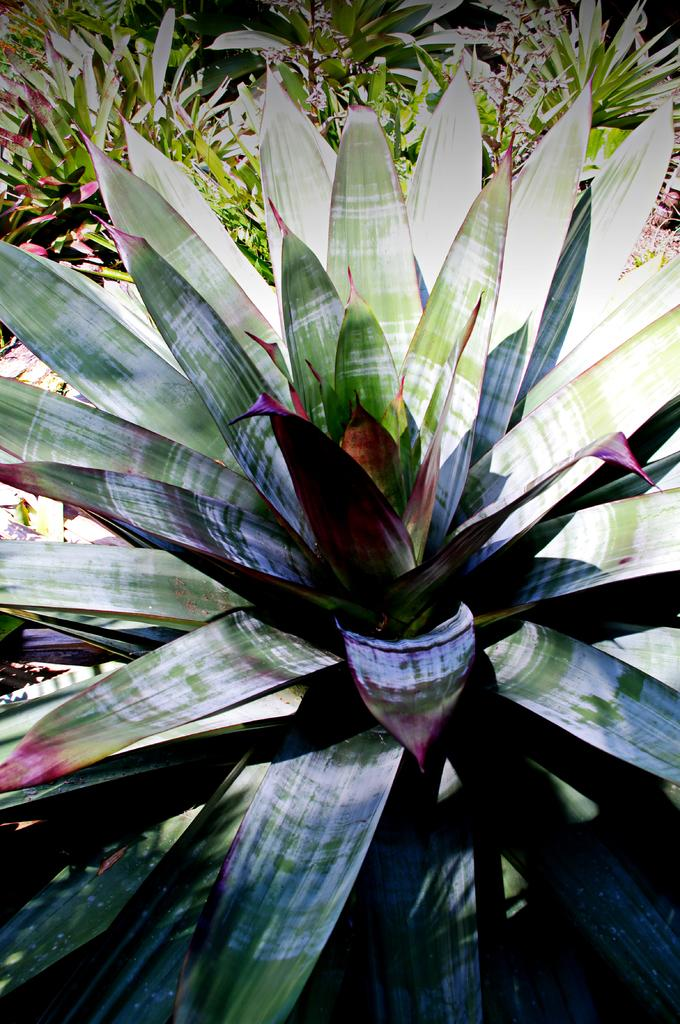What is the primary subject of the image? The primary subject of the image is many plants. Can you describe the plants in the image? Unfortunately, the provided facts do not give specific details about the plants. However, we can say that there are multiple plants visible in the image. Are there any other objects or elements in the image besides the plants? The provided facts do not mention any other objects or elements in the image. What type of paste is being used to create the scene in the image? There is no scene or paste present in the image; it features many plants. How does the image convey a sense of good-bye? The image does not convey a sense of good-bye, as it only contains many plants. 